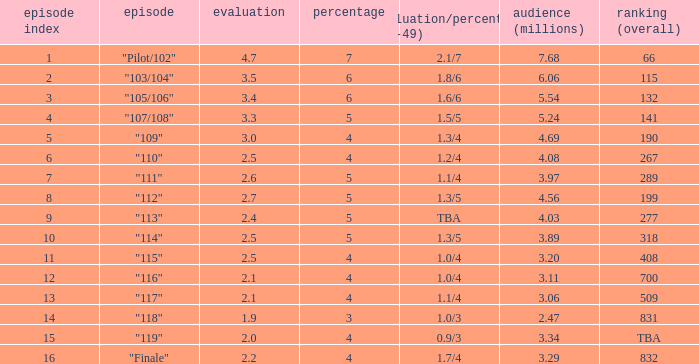WHAT IS THE NUMBER OF VIEWERS WITH EPISODE LARGER THAN 10, RATING SMALLER THAN 2? 2.47. 